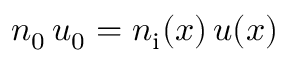<formula> <loc_0><loc_0><loc_500><loc_500>n _ { 0 } \, u _ { 0 } = n _ { i } ( x ) \, u ( x )</formula> 